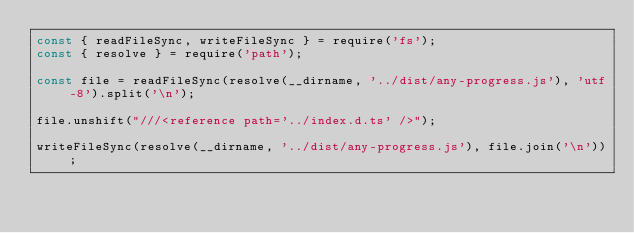Convert code to text. <code><loc_0><loc_0><loc_500><loc_500><_JavaScript_>const { readFileSync, writeFileSync } = require('fs');
const { resolve } = require('path');

const file = readFileSync(resolve(__dirname, '../dist/any-progress.js'), 'utf-8').split('\n');

file.unshift("///<reference path='../index.d.ts' />");

writeFileSync(resolve(__dirname, '../dist/any-progress.js'), file.join('\n'));
</code> 